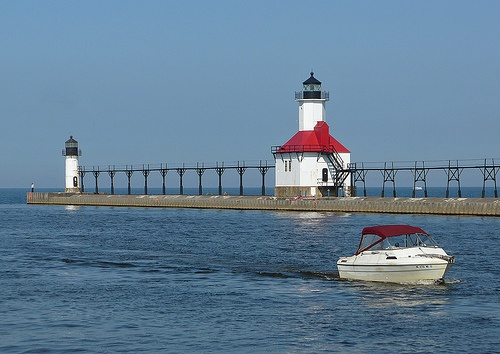Describe the objects in this image and their specific colors. I can see boat in darkgray, lightgray, gray, and maroon tones and people in darkgray, black, gray, and purple tones in this image. 